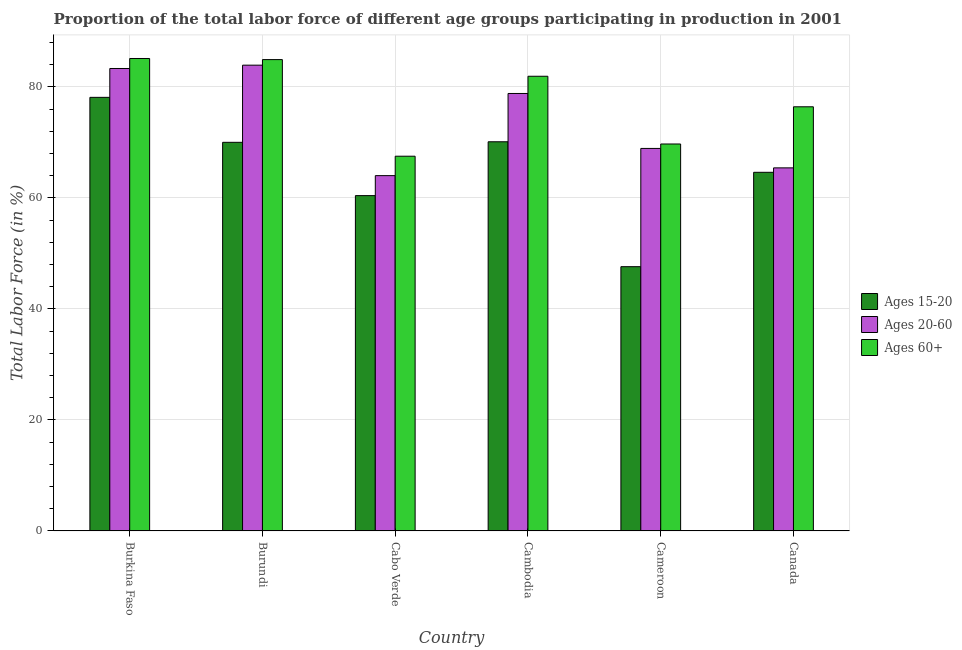How many different coloured bars are there?
Offer a terse response. 3. How many groups of bars are there?
Keep it short and to the point. 6. Are the number of bars per tick equal to the number of legend labels?
Offer a terse response. Yes. What is the label of the 3rd group of bars from the left?
Provide a short and direct response. Cabo Verde. In how many cases, is the number of bars for a given country not equal to the number of legend labels?
Your answer should be very brief. 0. What is the percentage of labor force above age 60 in Burundi?
Provide a succinct answer. 84.9. Across all countries, what is the maximum percentage of labor force above age 60?
Offer a very short reply. 85.1. Across all countries, what is the minimum percentage of labor force within the age group 15-20?
Your answer should be compact. 47.6. In which country was the percentage of labor force above age 60 maximum?
Your answer should be very brief. Burkina Faso. In which country was the percentage of labor force within the age group 20-60 minimum?
Your answer should be very brief. Cabo Verde. What is the total percentage of labor force above age 60 in the graph?
Offer a terse response. 465.5. What is the difference between the percentage of labor force within the age group 15-20 in Burundi and that in Cambodia?
Make the answer very short. -0.1. What is the difference between the percentage of labor force above age 60 in Canada and the percentage of labor force within the age group 20-60 in Burundi?
Ensure brevity in your answer.  -7.5. What is the average percentage of labor force within the age group 15-20 per country?
Provide a succinct answer. 65.13. What is the difference between the percentage of labor force above age 60 and percentage of labor force within the age group 15-20 in Cambodia?
Your response must be concise. 11.8. In how many countries, is the percentage of labor force above age 60 greater than 44 %?
Keep it short and to the point. 6. What is the ratio of the percentage of labor force within the age group 15-20 in Cambodia to that in Canada?
Make the answer very short. 1.09. Is the percentage of labor force within the age group 20-60 in Burkina Faso less than that in Canada?
Ensure brevity in your answer.  No. Is the difference between the percentage of labor force within the age group 20-60 in Cabo Verde and Cambodia greater than the difference between the percentage of labor force within the age group 15-20 in Cabo Verde and Cambodia?
Your response must be concise. No. What is the difference between the highest and the second highest percentage of labor force above age 60?
Give a very brief answer. 0.2. What is the difference between the highest and the lowest percentage of labor force within the age group 15-20?
Your answer should be very brief. 30.5. Is the sum of the percentage of labor force above age 60 in Burkina Faso and Canada greater than the maximum percentage of labor force within the age group 15-20 across all countries?
Keep it short and to the point. Yes. What does the 1st bar from the left in Cambodia represents?
Provide a succinct answer. Ages 15-20. What does the 3rd bar from the right in Cameroon represents?
Your response must be concise. Ages 15-20. Is it the case that in every country, the sum of the percentage of labor force within the age group 15-20 and percentage of labor force within the age group 20-60 is greater than the percentage of labor force above age 60?
Keep it short and to the point. Yes. How many bars are there?
Offer a terse response. 18. Are the values on the major ticks of Y-axis written in scientific E-notation?
Offer a terse response. No. Does the graph contain any zero values?
Your answer should be compact. No. What is the title of the graph?
Ensure brevity in your answer.  Proportion of the total labor force of different age groups participating in production in 2001. Does "Non-communicable diseases" appear as one of the legend labels in the graph?
Give a very brief answer. No. What is the label or title of the X-axis?
Provide a short and direct response. Country. What is the label or title of the Y-axis?
Offer a very short reply. Total Labor Force (in %). What is the Total Labor Force (in %) of Ages 15-20 in Burkina Faso?
Your answer should be compact. 78.1. What is the Total Labor Force (in %) in Ages 20-60 in Burkina Faso?
Provide a succinct answer. 83.3. What is the Total Labor Force (in %) of Ages 60+ in Burkina Faso?
Keep it short and to the point. 85.1. What is the Total Labor Force (in %) of Ages 20-60 in Burundi?
Your answer should be compact. 83.9. What is the Total Labor Force (in %) of Ages 60+ in Burundi?
Provide a succinct answer. 84.9. What is the Total Labor Force (in %) in Ages 15-20 in Cabo Verde?
Your response must be concise. 60.4. What is the Total Labor Force (in %) of Ages 60+ in Cabo Verde?
Keep it short and to the point. 67.5. What is the Total Labor Force (in %) in Ages 15-20 in Cambodia?
Your response must be concise. 70.1. What is the Total Labor Force (in %) of Ages 20-60 in Cambodia?
Provide a short and direct response. 78.8. What is the Total Labor Force (in %) in Ages 60+ in Cambodia?
Offer a terse response. 81.9. What is the Total Labor Force (in %) in Ages 15-20 in Cameroon?
Your response must be concise. 47.6. What is the Total Labor Force (in %) of Ages 20-60 in Cameroon?
Provide a short and direct response. 68.9. What is the Total Labor Force (in %) of Ages 60+ in Cameroon?
Ensure brevity in your answer.  69.7. What is the Total Labor Force (in %) in Ages 15-20 in Canada?
Your answer should be compact. 64.6. What is the Total Labor Force (in %) of Ages 20-60 in Canada?
Offer a very short reply. 65.4. What is the Total Labor Force (in %) in Ages 60+ in Canada?
Your answer should be compact. 76.4. Across all countries, what is the maximum Total Labor Force (in %) of Ages 15-20?
Keep it short and to the point. 78.1. Across all countries, what is the maximum Total Labor Force (in %) in Ages 20-60?
Your answer should be very brief. 83.9. Across all countries, what is the maximum Total Labor Force (in %) of Ages 60+?
Offer a very short reply. 85.1. Across all countries, what is the minimum Total Labor Force (in %) in Ages 15-20?
Offer a very short reply. 47.6. Across all countries, what is the minimum Total Labor Force (in %) of Ages 20-60?
Keep it short and to the point. 64. Across all countries, what is the minimum Total Labor Force (in %) in Ages 60+?
Offer a very short reply. 67.5. What is the total Total Labor Force (in %) of Ages 15-20 in the graph?
Your answer should be very brief. 390.8. What is the total Total Labor Force (in %) in Ages 20-60 in the graph?
Give a very brief answer. 444.3. What is the total Total Labor Force (in %) in Ages 60+ in the graph?
Your answer should be compact. 465.5. What is the difference between the Total Labor Force (in %) of Ages 15-20 in Burkina Faso and that in Burundi?
Keep it short and to the point. 8.1. What is the difference between the Total Labor Force (in %) in Ages 20-60 in Burkina Faso and that in Burundi?
Provide a short and direct response. -0.6. What is the difference between the Total Labor Force (in %) in Ages 60+ in Burkina Faso and that in Burundi?
Provide a short and direct response. 0.2. What is the difference between the Total Labor Force (in %) in Ages 20-60 in Burkina Faso and that in Cabo Verde?
Give a very brief answer. 19.3. What is the difference between the Total Labor Force (in %) of Ages 60+ in Burkina Faso and that in Cabo Verde?
Provide a succinct answer. 17.6. What is the difference between the Total Labor Force (in %) of Ages 15-20 in Burkina Faso and that in Cambodia?
Your answer should be very brief. 8. What is the difference between the Total Labor Force (in %) in Ages 60+ in Burkina Faso and that in Cambodia?
Your response must be concise. 3.2. What is the difference between the Total Labor Force (in %) in Ages 15-20 in Burkina Faso and that in Cameroon?
Offer a terse response. 30.5. What is the difference between the Total Labor Force (in %) in Ages 15-20 in Burundi and that in Cameroon?
Provide a succinct answer. 22.4. What is the difference between the Total Labor Force (in %) in Ages 60+ in Burundi and that in Canada?
Offer a terse response. 8.5. What is the difference between the Total Labor Force (in %) in Ages 15-20 in Cabo Verde and that in Cambodia?
Provide a succinct answer. -9.7. What is the difference between the Total Labor Force (in %) in Ages 20-60 in Cabo Verde and that in Cambodia?
Make the answer very short. -14.8. What is the difference between the Total Labor Force (in %) of Ages 60+ in Cabo Verde and that in Cambodia?
Your answer should be compact. -14.4. What is the difference between the Total Labor Force (in %) in Ages 15-20 in Cabo Verde and that in Cameroon?
Make the answer very short. 12.8. What is the difference between the Total Labor Force (in %) of Ages 60+ in Cabo Verde and that in Canada?
Give a very brief answer. -8.9. What is the difference between the Total Labor Force (in %) in Ages 20-60 in Cambodia and that in Cameroon?
Offer a terse response. 9.9. What is the difference between the Total Labor Force (in %) of Ages 15-20 in Cambodia and that in Canada?
Your response must be concise. 5.5. What is the difference between the Total Labor Force (in %) of Ages 20-60 in Cambodia and that in Canada?
Offer a very short reply. 13.4. What is the difference between the Total Labor Force (in %) of Ages 20-60 in Cameroon and that in Canada?
Ensure brevity in your answer.  3.5. What is the difference between the Total Labor Force (in %) of Ages 60+ in Cameroon and that in Canada?
Keep it short and to the point. -6.7. What is the difference between the Total Labor Force (in %) of Ages 20-60 in Burkina Faso and the Total Labor Force (in %) of Ages 60+ in Burundi?
Make the answer very short. -1.6. What is the difference between the Total Labor Force (in %) of Ages 20-60 in Burkina Faso and the Total Labor Force (in %) of Ages 60+ in Cabo Verde?
Provide a short and direct response. 15.8. What is the difference between the Total Labor Force (in %) in Ages 15-20 in Burkina Faso and the Total Labor Force (in %) in Ages 20-60 in Cambodia?
Ensure brevity in your answer.  -0.7. What is the difference between the Total Labor Force (in %) of Ages 15-20 in Burkina Faso and the Total Labor Force (in %) of Ages 60+ in Cambodia?
Your answer should be compact. -3.8. What is the difference between the Total Labor Force (in %) in Ages 15-20 in Burkina Faso and the Total Labor Force (in %) in Ages 60+ in Cameroon?
Offer a very short reply. 8.4. What is the difference between the Total Labor Force (in %) in Ages 20-60 in Burkina Faso and the Total Labor Force (in %) in Ages 60+ in Cameroon?
Keep it short and to the point. 13.6. What is the difference between the Total Labor Force (in %) in Ages 15-20 in Burkina Faso and the Total Labor Force (in %) in Ages 20-60 in Canada?
Your answer should be compact. 12.7. What is the difference between the Total Labor Force (in %) of Ages 15-20 in Burkina Faso and the Total Labor Force (in %) of Ages 60+ in Canada?
Make the answer very short. 1.7. What is the difference between the Total Labor Force (in %) of Ages 15-20 in Burundi and the Total Labor Force (in %) of Ages 20-60 in Cabo Verde?
Give a very brief answer. 6. What is the difference between the Total Labor Force (in %) in Ages 15-20 in Burundi and the Total Labor Force (in %) in Ages 20-60 in Cambodia?
Your answer should be very brief. -8.8. What is the difference between the Total Labor Force (in %) in Ages 15-20 in Burundi and the Total Labor Force (in %) in Ages 60+ in Cameroon?
Your answer should be very brief. 0.3. What is the difference between the Total Labor Force (in %) in Ages 15-20 in Cabo Verde and the Total Labor Force (in %) in Ages 20-60 in Cambodia?
Offer a very short reply. -18.4. What is the difference between the Total Labor Force (in %) in Ages 15-20 in Cabo Verde and the Total Labor Force (in %) in Ages 60+ in Cambodia?
Ensure brevity in your answer.  -21.5. What is the difference between the Total Labor Force (in %) of Ages 20-60 in Cabo Verde and the Total Labor Force (in %) of Ages 60+ in Cambodia?
Your response must be concise. -17.9. What is the difference between the Total Labor Force (in %) of Ages 20-60 in Cabo Verde and the Total Labor Force (in %) of Ages 60+ in Cameroon?
Give a very brief answer. -5.7. What is the difference between the Total Labor Force (in %) in Ages 15-20 in Cabo Verde and the Total Labor Force (in %) in Ages 20-60 in Canada?
Keep it short and to the point. -5. What is the difference between the Total Labor Force (in %) of Ages 15-20 in Cambodia and the Total Labor Force (in %) of Ages 20-60 in Cameroon?
Provide a short and direct response. 1.2. What is the difference between the Total Labor Force (in %) in Ages 20-60 in Cambodia and the Total Labor Force (in %) in Ages 60+ in Cameroon?
Offer a very short reply. 9.1. What is the difference between the Total Labor Force (in %) in Ages 15-20 in Cambodia and the Total Labor Force (in %) in Ages 60+ in Canada?
Provide a short and direct response. -6.3. What is the difference between the Total Labor Force (in %) in Ages 20-60 in Cambodia and the Total Labor Force (in %) in Ages 60+ in Canada?
Keep it short and to the point. 2.4. What is the difference between the Total Labor Force (in %) in Ages 15-20 in Cameroon and the Total Labor Force (in %) in Ages 20-60 in Canada?
Keep it short and to the point. -17.8. What is the difference between the Total Labor Force (in %) in Ages 15-20 in Cameroon and the Total Labor Force (in %) in Ages 60+ in Canada?
Provide a short and direct response. -28.8. What is the difference between the Total Labor Force (in %) of Ages 20-60 in Cameroon and the Total Labor Force (in %) of Ages 60+ in Canada?
Keep it short and to the point. -7.5. What is the average Total Labor Force (in %) in Ages 15-20 per country?
Keep it short and to the point. 65.13. What is the average Total Labor Force (in %) in Ages 20-60 per country?
Ensure brevity in your answer.  74.05. What is the average Total Labor Force (in %) of Ages 60+ per country?
Ensure brevity in your answer.  77.58. What is the difference between the Total Labor Force (in %) in Ages 15-20 and Total Labor Force (in %) in Ages 20-60 in Burkina Faso?
Offer a very short reply. -5.2. What is the difference between the Total Labor Force (in %) in Ages 15-20 and Total Labor Force (in %) in Ages 60+ in Burkina Faso?
Your response must be concise. -7. What is the difference between the Total Labor Force (in %) of Ages 15-20 and Total Labor Force (in %) of Ages 20-60 in Burundi?
Offer a terse response. -13.9. What is the difference between the Total Labor Force (in %) of Ages 15-20 and Total Labor Force (in %) of Ages 60+ in Burundi?
Offer a very short reply. -14.9. What is the difference between the Total Labor Force (in %) of Ages 20-60 and Total Labor Force (in %) of Ages 60+ in Burundi?
Provide a succinct answer. -1. What is the difference between the Total Labor Force (in %) of Ages 15-20 and Total Labor Force (in %) of Ages 20-60 in Cabo Verde?
Keep it short and to the point. -3.6. What is the difference between the Total Labor Force (in %) in Ages 20-60 and Total Labor Force (in %) in Ages 60+ in Cabo Verde?
Your answer should be very brief. -3.5. What is the difference between the Total Labor Force (in %) of Ages 15-20 and Total Labor Force (in %) of Ages 20-60 in Cameroon?
Your response must be concise. -21.3. What is the difference between the Total Labor Force (in %) of Ages 15-20 and Total Labor Force (in %) of Ages 60+ in Cameroon?
Make the answer very short. -22.1. What is the difference between the Total Labor Force (in %) in Ages 20-60 and Total Labor Force (in %) in Ages 60+ in Cameroon?
Ensure brevity in your answer.  -0.8. What is the difference between the Total Labor Force (in %) of Ages 15-20 and Total Labor Force (in %) of Ages 20-60 in Canada?
Provide a succinct answer. -0.8. What is the difference between the Total Labor Force (in %) in Ages 15-20 and Total Labor Force (in %) in Ages 60+ in Canada?
Provide a succinct answer. -11.8. What is the difference between the Total Labor Force (in %) in Ages 20-60 and Total Labor Force (in %) in Ages 60+ in Canada?
Give a very brief answer. -11. What is the ratio of the Total Labor Force (in %) of Ages 15-20 in Burkina Faso to that in Burundi?
Offer a very short reply. 1.12. What is the ratio of the Total Labor Force (in %) of Ages 20-60 in Burkina Faso to that in Burundi?
Make the answer very short. 0.99. What is the ratio of the Total Labor Force (in %) of Ages 15-20 in Burkina Faso to that in Cabo Verde?
Ensure brevity in your answer.  1.29. What is the ratio of the Total Labor Force (in %) in Ages 20-60 in Burkina Faso to that in Cabo Verde?
Offer a very short reply. 1.3. What is the ratio of the Total Labor Force (in %) in Ages 60+ in Burkina Faso to that in Cabo Verde?
Offer a terse response. 1.26. What is the ratio of the Total Labor Force (in %) in Ages 15-20 in Burkina Faso to that in Cambodia?
Your response must be concise. 1.11. What is the ratio of the Total Labor Force (in %) in Ages 20-60 in Burkina Faso to that in Cambodia?
Provide a succinct answer. 1.06. What is the ratio of the Total Labor Force (in %) of Ages 60+ in Burkina Faso to that in Cambodia?
Ensure brevity in your answer.  1.04. What is the ratio of the Total Labor Force (in %) of Ages 15-20 in Burkina Faso to that in Cameroon?
Your response must be concise. 1.64. What is the ratio of the Total Labor Force (in %) of Ages 20-60 in Burkina Faso to that in Cameroon?
Ensure brevity in your answer.  1.21. What is the ratio of the Total Labor Force (in %) in Ages 60+ in Burkina Faso to that in Cameroon?
Your response must be concise. 1.22. What is the ratio of the Total Labor Force (in %) of Ages 15-20 in Burkina Faso to that in Canada?
Offer a very short reply. 1.21. What is the ratio of the Total Labor Force (in %) of Ages 20-60 in Burkina Faso to that in Canada?
Keep it short and to the point. 1.27. What is the ratio of the Total Labor Force (in %) in Ages 60+ in Burkina Faso to that in Canada?
Offer a very short reply. 1.11. What is the ratio of the Total Labor Force (in %) of Ages 15-20 in Burundi to that in Cabo Verde?
Keep it short and to the point. 1.16. What is the ratio of the Total Labor Force (in %) of Ages 20-60 in Burundi to that in Cabo Verde?
Give a very brief answer. 1.31. What is the ratio of the Total Labor Force (in %) of Ages 60+ in Burundi to that in Cabo Verde?
Offer a terse response. 1.26. What is the ratio of the Total Labor Force (in %) of Ages 15-20 in Burundi to that in Cambodia?
Ensure brevity in your answer.  1. What is the ratio of the Total Labor Force (in %) in Ages 20-60 in Burundi to that in Cambodia?
Give a very brief answer. 1.06. What is the ratio of the Total Labor Force (in %) of Ages 60+ in Burundi to that in Cambodia?
Your response must be concise. 1.04. What is the ratio of the Total Labor Force (in %) in Ages 15-20 in Burundi to that in Cameroon?
Offer a terse response. 1.47. What is the ratio of the Total Labor Force (in %) in Ages 20-60 in Burundi to that in Cameroon?
Your answer should be very brief. 1.22. What is the ratio of the Total Labor Force (in %) of Ages 60+ in Burundi to that in Cameroon?
Keep it short and to the point. 1.22. What is the ratio of the Total Labor Force (in %) in Ages 15-20 in Burundi to that in Canada?
Provide a succinct answer. 1.08. What is the ratio of the Total Labor Force (in %) of Ages 20-60 in Burundi to that in Canada?
Your response must be concise. 1.28. What is the ratio of the Total Labor Force (in %) in Ages 60+ in Burundi to that in Canada?
Your answer should be compact. 1.11. What is the ratio of the Total Labor Force (in %) in Ages 15-20 in Cabo Verde to that in Cambodia?
Offer a very short reply. 0.86. What is the ratio of the Total Labor Force (in %) of Ages 20-60 in Cabo Verde to that in Cambodia?
Make the answer very short. 0.81. What is the ratio of the Total Labor Force (in %) in Ages 60+ in Cabo Verde to that in Cambodia?
Give a very brief answer. 0.82. What is the ratio of the Total Labor Force (in %) of Ages 15-20 in Cabo Verde to that in Cameroon?
Make the answer very short. 1.27. What is the ratio of the Total Labor Force (in %) of Ages 20-60 in Cabo Verde to that in Cameroon?
Provide a short and direct response. 0.93. What is the ratio of the Total Labor Force (in %) in Ages 60+ in Cabo Verde to that in Cameroon?
Offer a very short reply. 0.97. What is the ratio of the Total Labor Force (in %) in Ages 15-20 in Cabo Verde to that in Canada?
Offer a terse response. 0.94. What is the ratio of the Total Labor Force (in %) of Ages 20-60 in Cabo Verde to that in Canada?
Give a very brief answer. 0.98. What is the ratio of the Total Labor Force (in %) in Ages 60+ in Cabo Verde to that in Canada?
Offer a terse response. 0.88. What is the ratio of the Total Labor Force (in %) of Ages 15-20 in Cambodia to that in Cameroon?
Provide a succinct answer. 1.47. What is the ratio of the Total Labor Force (in %) of Ages 20-60 in Cambodia to that in Cameroon?
Your answer should be compact. 1.14. What is the ratio of the Total Labor Force (in %) of Ages 60+ in Cambodia to that in Cameroon?
Provide a short and direct response. 1.18. What is the ratio of the Total Labor Force (in %) of Ages 15-20 in Cambodia to that in Canada?
Make the answer very short. 1.09. What is the ratio of the Total Labor Force (in %) of Ages 20-60 in Cambodia to that in Canada?
Provide a short and direct response. 1.2. What is the ratio of the Total Labor Force (in %) of Ages 60+ in Cambodia to that in Canada?
Your answer should be compact. 1.07. What is the ratio of the Total Labor Force (in %) of Ages 15-20 in Cameroon to that in Canada?
Ensure brevity in your answer.  0.74. What is the ratio of the Total Labor Force (in %) of Ages 20-60 in Cameroon to that in Canada?
Offer a terse response. 1.05. What is the ratio of the Total Labor Force (in %) in Ages 60+ in Cameroon to that in Canada?
Offer a terse response. 0.91. What is the difference between the highest and the second highest Total Labor Force (in %) of Ages 15-20?
Provide a short and direct response. 8. What is the difference between the highest and the lowest Total Labor Force (in %) of Ages 15-20?
Offer a terse response. 30.5. What is the difference between the highest and the lowest Total Labor Force (in %) in Ages 20-60?
Make the answer very short. 19.9. What is the difference between the highest and the lowest Total Labor Force (in %) of Ages 60+?
Give a very brief answer. 17.6. 